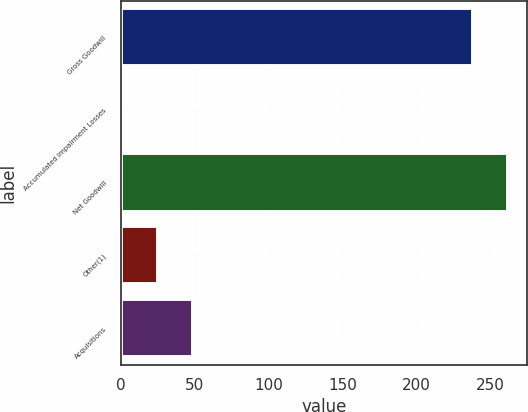<chart> <loc_0><loc_0><loc_500><loc_500><bar_chart><fcel>Gross Goodwill<fcel>Accumulated Impairment Losses<fcel>Net Goodwill<fcel>Other(1)<fcel>Acquisitions<nl><fcel>238<fcel>1.4<fcel>261.66<fcel>25.06<fcel>48.72<nl></chart> 